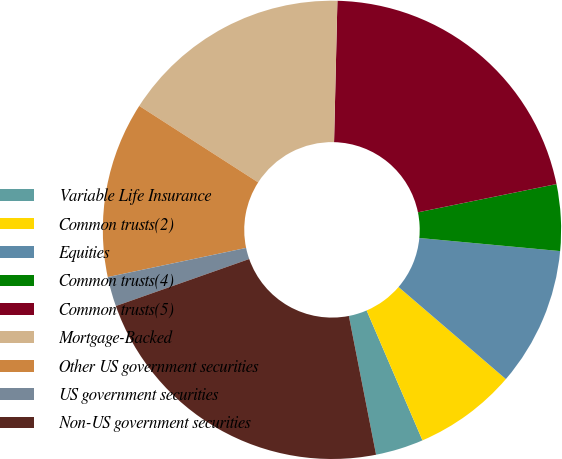Convert chart to OTSL. <chart><loc_0><loc_0><loc_500><loc_500><pie_chart><fcel>Variable Life Insurance<fcel>Common trusts(2)<fcel>Equities<fcel>Common trusts(4)<fcel>Common trusts(5)<fcel>Mortgage-Backed<fcel>Other US government securities<fcel>US government securities<fcel>Non-US government securities<nl><fcel>3.38%<fcel>7.25%<fcel>9.81%<fcel>4.68%<fcel>21.42%<fcel>16.28%<fcel>12.4%<fcel>2.09%<fcel>22.69%<nl></chart> 